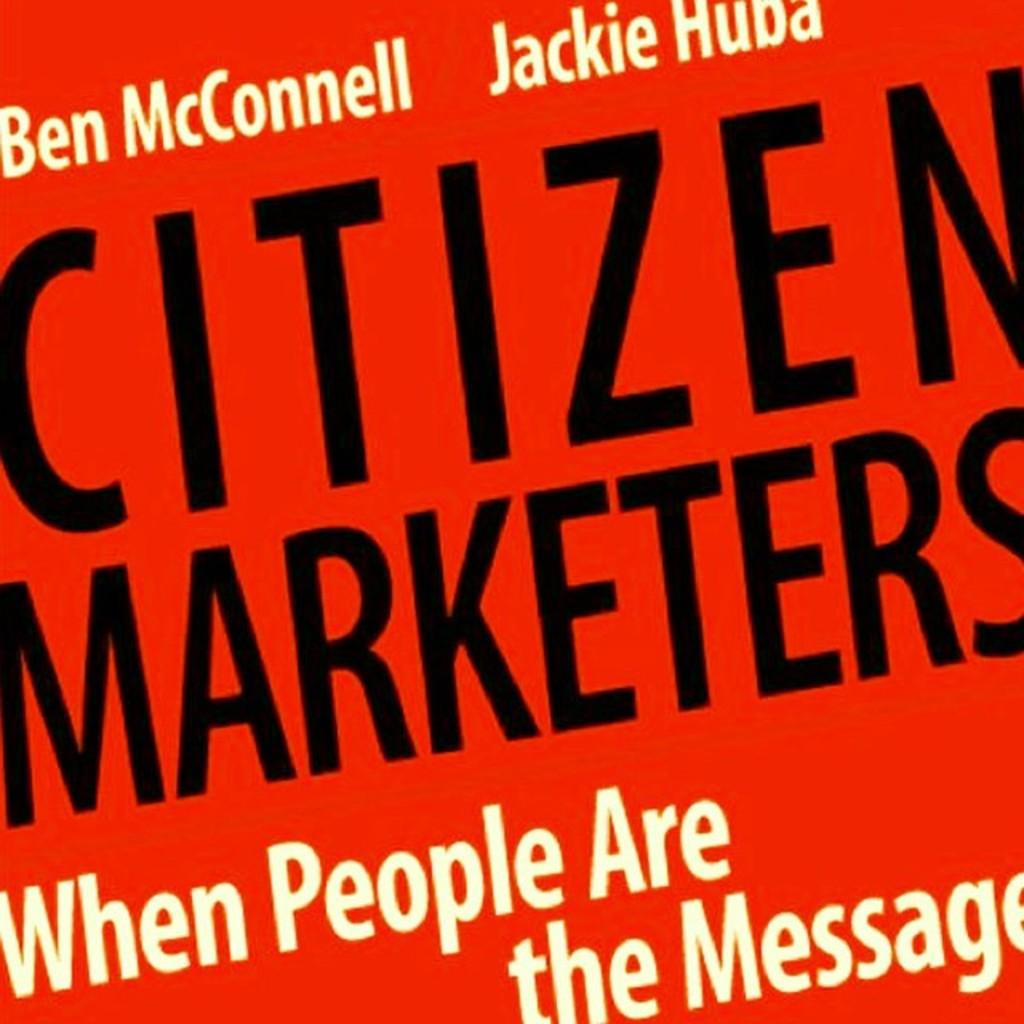<image>
Create a compact narrative representing the image presented. The red book cover with the title "Citizen Marketers" in black. 